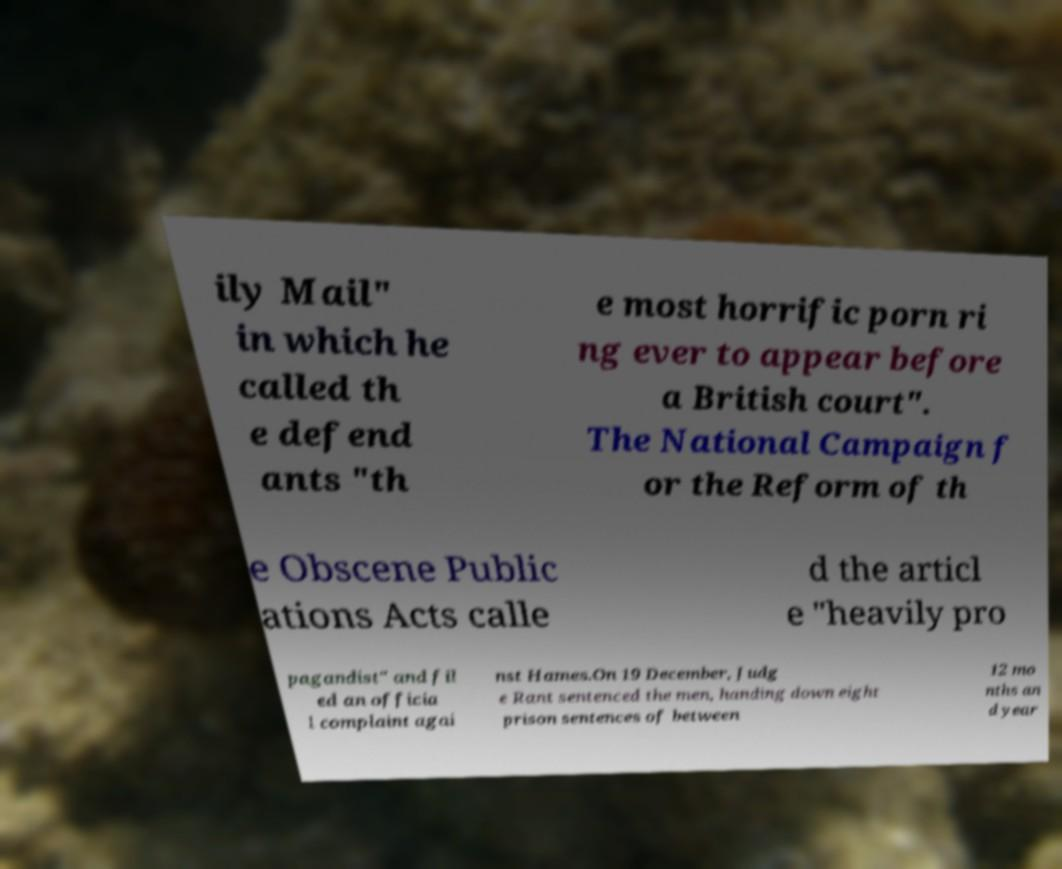Could you extract and type out the text from this image? ily Mail" in which he called th e defend ants "th e most horrific porn ri ng ever to appear before a British court". The National Campaign f or the Reform of th e Obscene Public ations Acts calle d the articl e "heavily pro pagandist" and fil ed an officia l complaint agai nst Hames.On 19 December, Judg e Rant sentenced the men, handing down eight prison sentences of between 12 mo nths an d year 